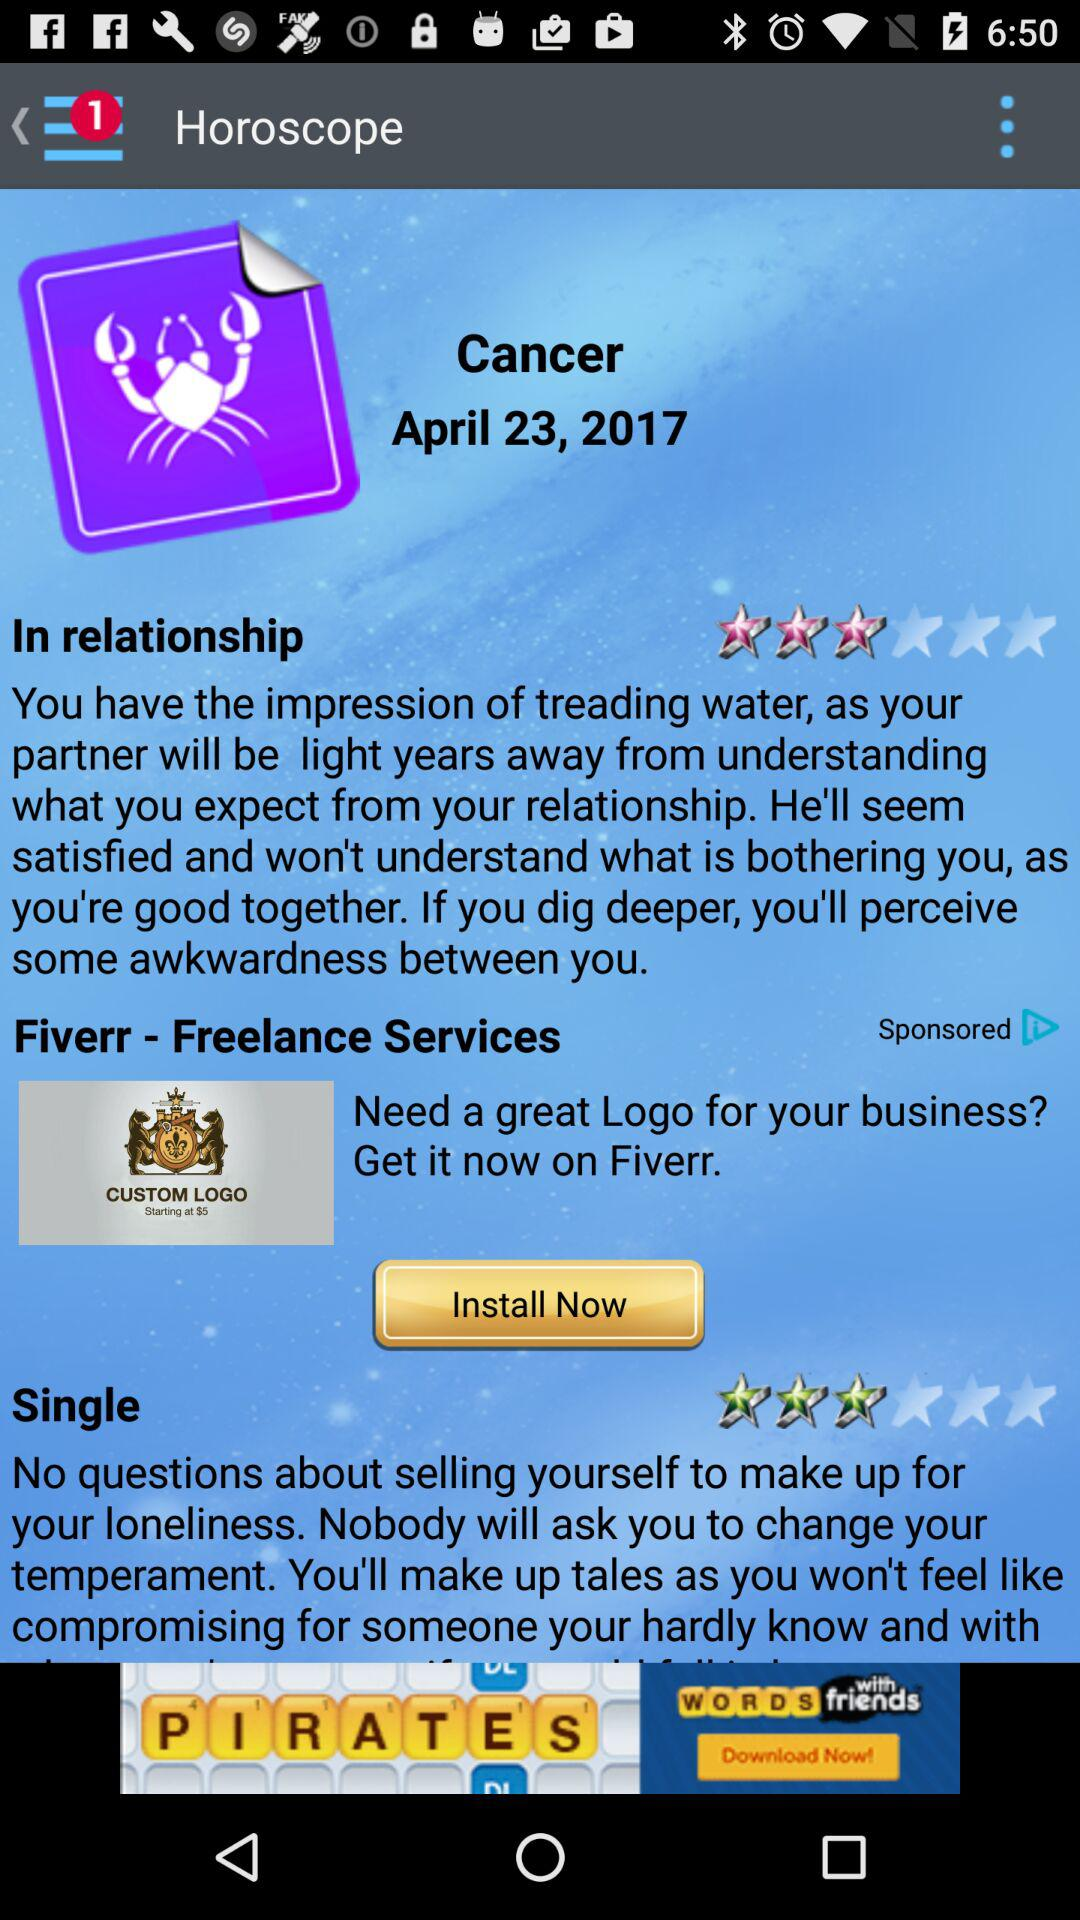What is the mentioned horoscope? The mentioned horoscope is Cancer. 